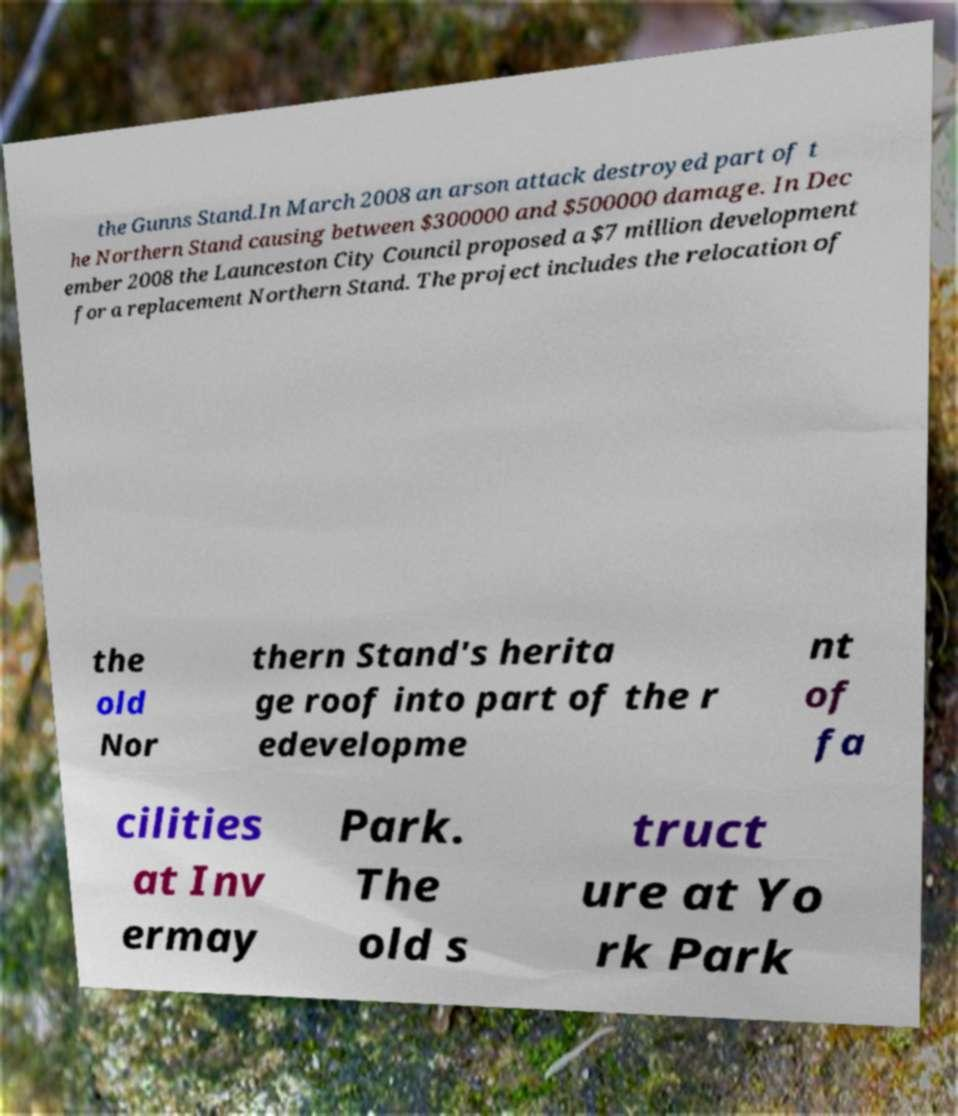Can you read and provide the text displayed in the image?This photo seems to have some interesting text. Can you extract and type it out for me? the Gunns Stand.In March 2008 an arson attack destroyed part of t he Northern Stand causing between $300000 and $500000 damage. In Dec ember 2008 the Launceston City Council proposed a $7 million development for a replacement Northern Stand. The project includes the relocation of the old Nor thern Stand's herita ge roof into part of the r edevelopme nt of fa cilities at Inv ermay Park. The old s truct ure at Yo rk Park 